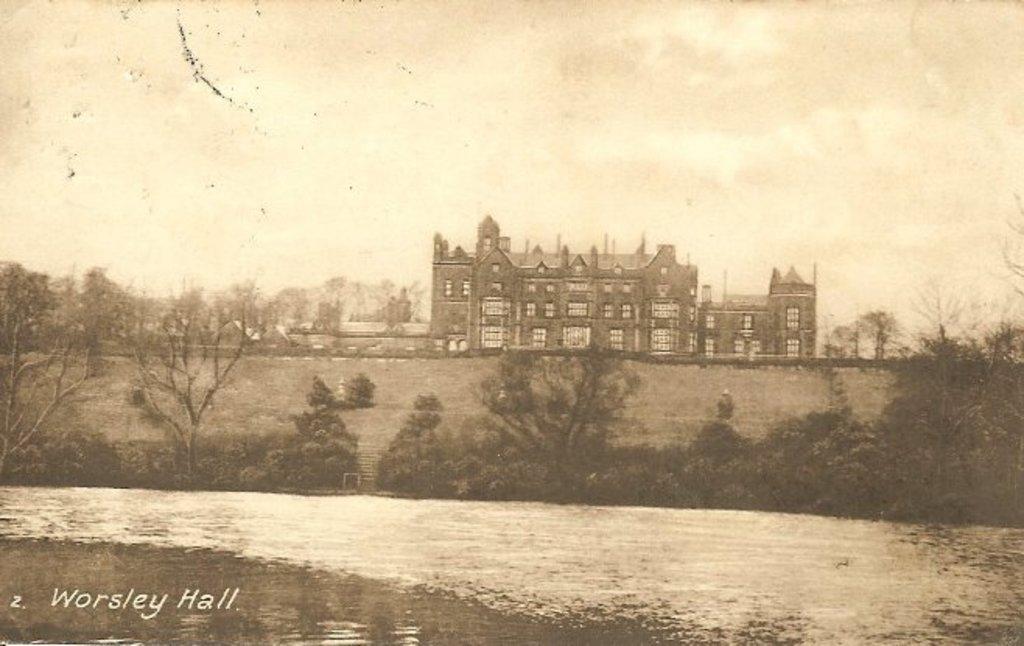In one or two sentences, can you explain what this image depicts? A black and white picture. Building with windows. In-front of this building there are trees. Bottom of the image there is a watermark. 